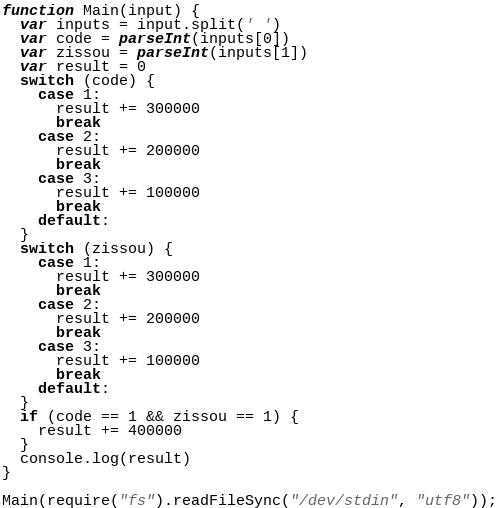Convert code to text. <code><loc_0><loc_0><loc_500><loc_500><_JavaScript_>function Main(input) {
  var inputs = input.split(' ')
  var code = parseInt(inputs[0])
  var zissou = parseInt(inputs[1])
  var result = 0
  switch (code) {
    case 1:
      result += 300000
      break
    case 2:
      result += 200000
      break
    case 3:
      result += 100000
      break
    default:
  }
  switch (zissou) {
    case 1:
      result += 300000
      break
    case 2:
      result += 200000
      break
    case 3:
      result += 100000
      break
    default:
  }
  if (code == 1 && zissou == 1) {
    result += 400000
  }
  console.log(result)
}

Main(require("fs").readFileSync("/dev/stdin", "utf8"));</code> 